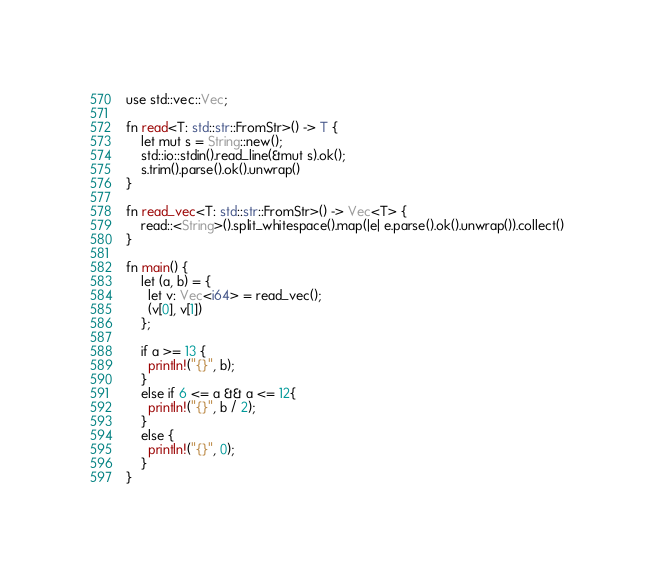<code> <loc_0><loc_0><loc_500><loc_500><_Rust_>use std::vec::Vec;

fn read<T: std::str::FromStr>() -> T {
    let mut s = String::new();
    std::io::stdin().read_line(&mut s).ok();
    s.trim().parse().ok().unwrap()
}

fn read_vec<T: std::str::FromStr>() -> Vec<T> {
    read::<String>().split_whitespace().map(|e| e.parse().ok().unwrap()).collect()
}

fn main() {
    let (a, b) = {
      let v: Vec<i64> = read_vec();
      (v[0], v[1])
    };

    if a >= 13 {
      println!("{}", b);
    }
    else if 6 <= a && a <= 12{
      println!("{}", b / 2);
    }
    else {
      println!("{}", 0);
    }
}
</code> 